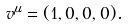Convert formula to latex. <formula><loc_0><loc_0><loc_500><loc_500>v ^ { \mu } = ( 1 , 0 , 0 , 0 ) .</formula> 